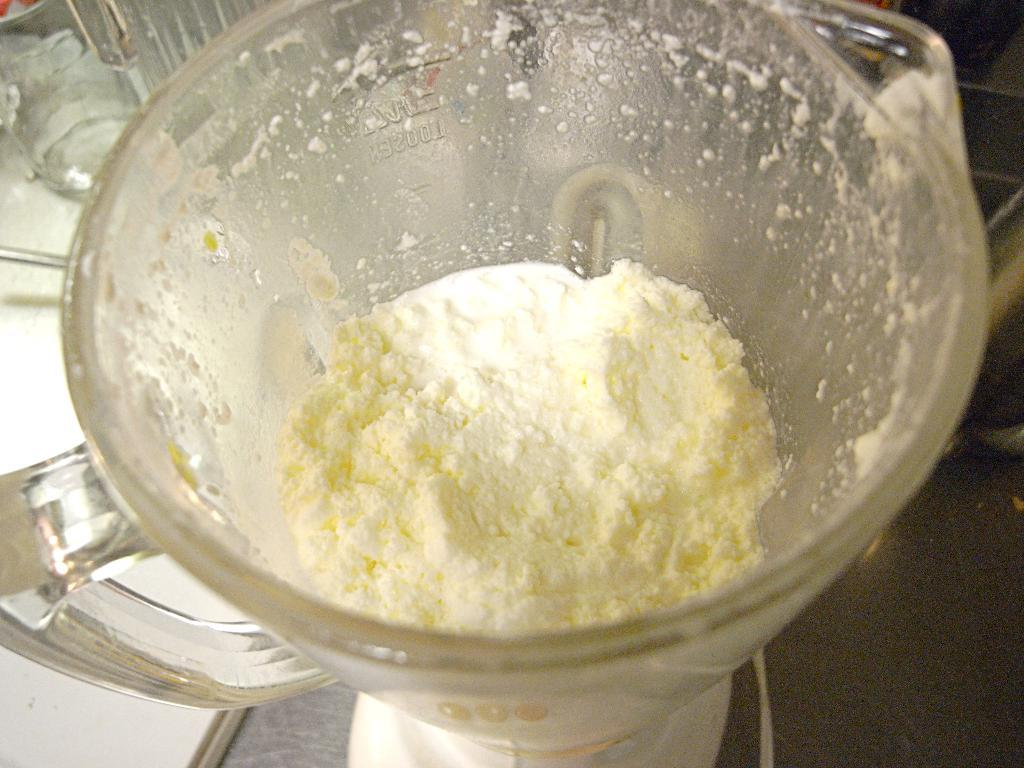What is being processed in the image? There is food in a food processor in the image. Can you describe the food being processed? Unfortunately, the specific type of food cannot be determined from the image. What is the purpose of the food processor in the image? The food processor is being used to process the food. How does the sock blow in the wind in the image? There is no sock or wind present in the image; it only features a food processor with food inside. 